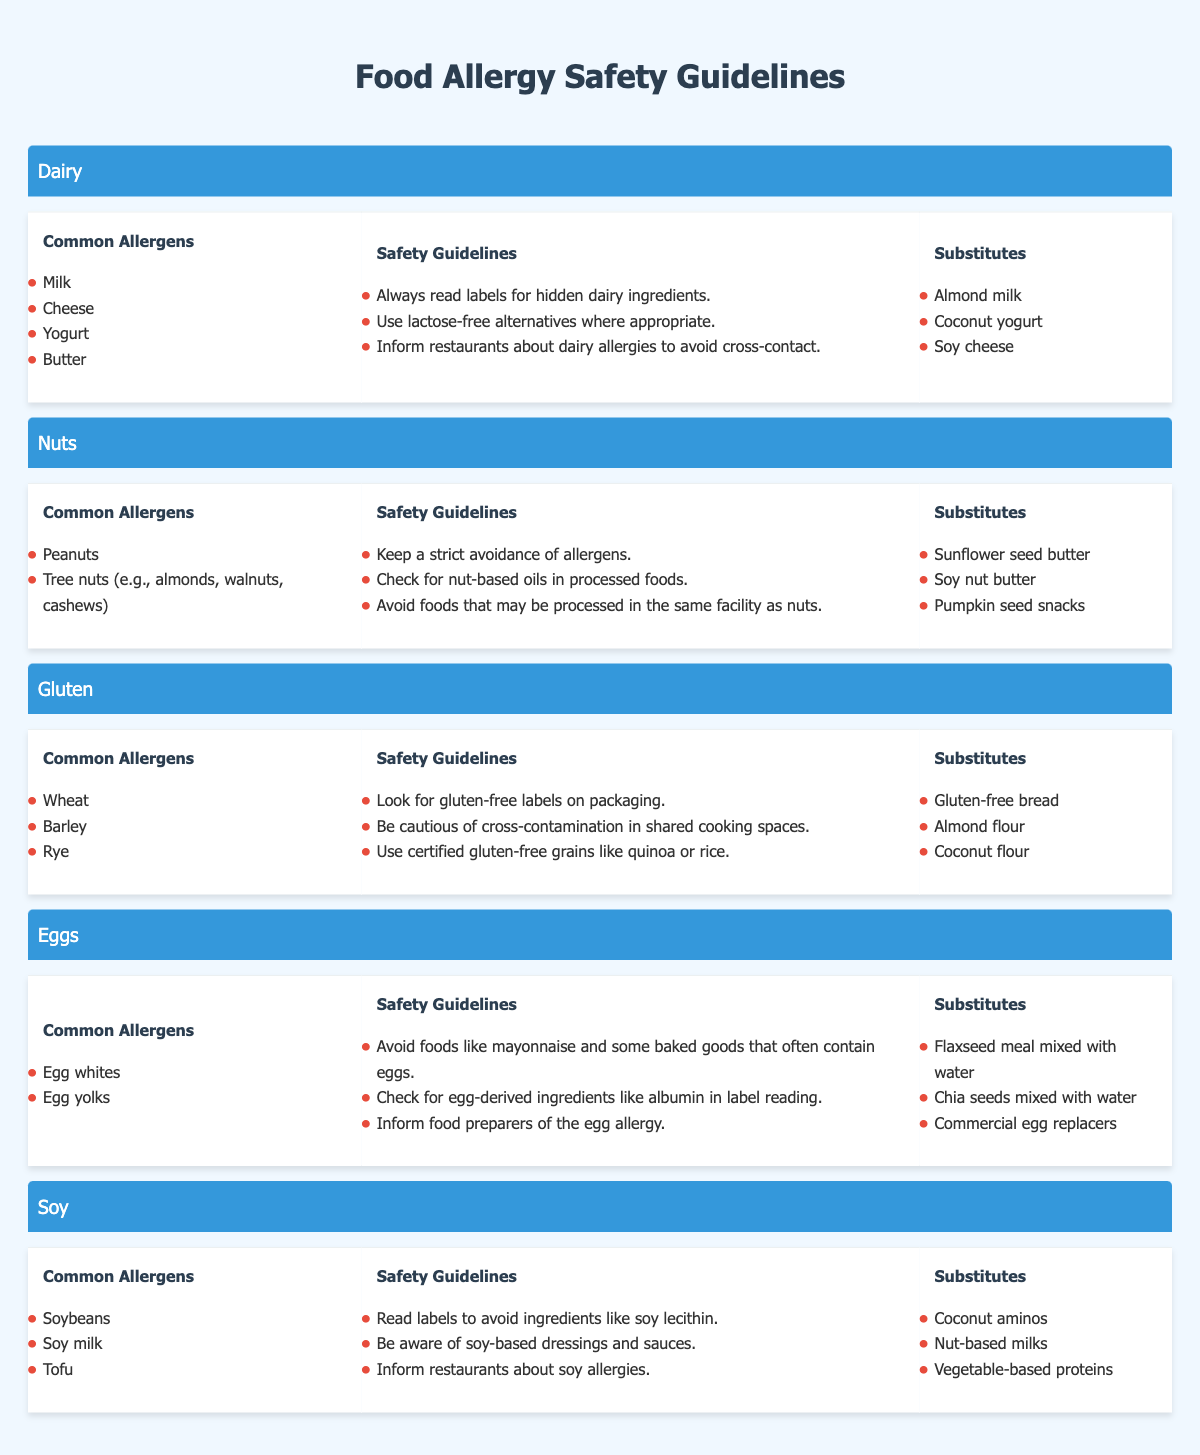What are the common allergens in dairy? The table lists the common allergens under the "Dairy" category, which include "Milk," "Cheese," "Yogurt," and "Butter."
Answer: Milk, Cheese, Yogurt, Butter What safety guideline is recommended for avoiding dairy allergens? The table provides several safety guidelines for dairy. One of them states, "Always read labels for hidden dairy ingredients," which is a key recommendation when dealing with dairy allergies.
Answer: Always read labels for hidden dairy ingredients How many substitutes are listed for eggs? The "Eggs" section of the table contains a list with three substitutes: "Flaxseed meal mixed with water," "Chia seeds mixed with water," and "Commercial egg replacers." Since there are three items, the total is 3 substitutes.
Answer: 3 Are sunflower seed butter and pumpkin seed snacks recommended substitutes for nuts? The "Nuts" section lists "Sunflower seed butter," "Soy nut butter," and "Pumpkin seed snacks" as substitutes. Therefore, both are recommended substitutes.
Answer: Yes Which category includes the common allergens "Wheat," "Barley," and "Rye"? By examining the sections of the table, it's evident that these common allergens are listed under the "Gluten" category.
Answer: Gluten What is the total number of common allergens across all categories? The count of allergens is as follows: Dairy (4), Nuts (2), Gluten (3), Eggs (2), and Soy (3). Adding these gives a total: 4 + 2 + 3 + 2 + 3 = 14.
Answer: 14 Is it necessary to inform restaurants about soy allergies? The table states in the "Safety Guidelines" for soy that it is important to "Inform restaurants about soy allergies," thus confirming the necessity of this action.
Answer: Yes What are the safety guidelines for avoiding gluten contamination? The guidelines for gluten include: "Look for gluten-free labels on packaging," "Be cautious of cross-contamination in shared cooking spaces," and "Use certified gluten-free grains like quinoa or rice." These three guidelines emphasize different aspects of avoiding gluten contamination.
Answer: Look for gluten-free labels on packaging, Be cautious of cross-contamination, Use certified gluten-free grains Which substitutes are recommended for soy? The "Soy" section mentions three substitutes: "Coconut aminos," "Nut-based milks," and "Vegetable-based proteins." This provides a comprehensive alternative option for those with soy allergies.
Answer: Coconut aminos, Nut-based milks, Vegetable-based proteins 